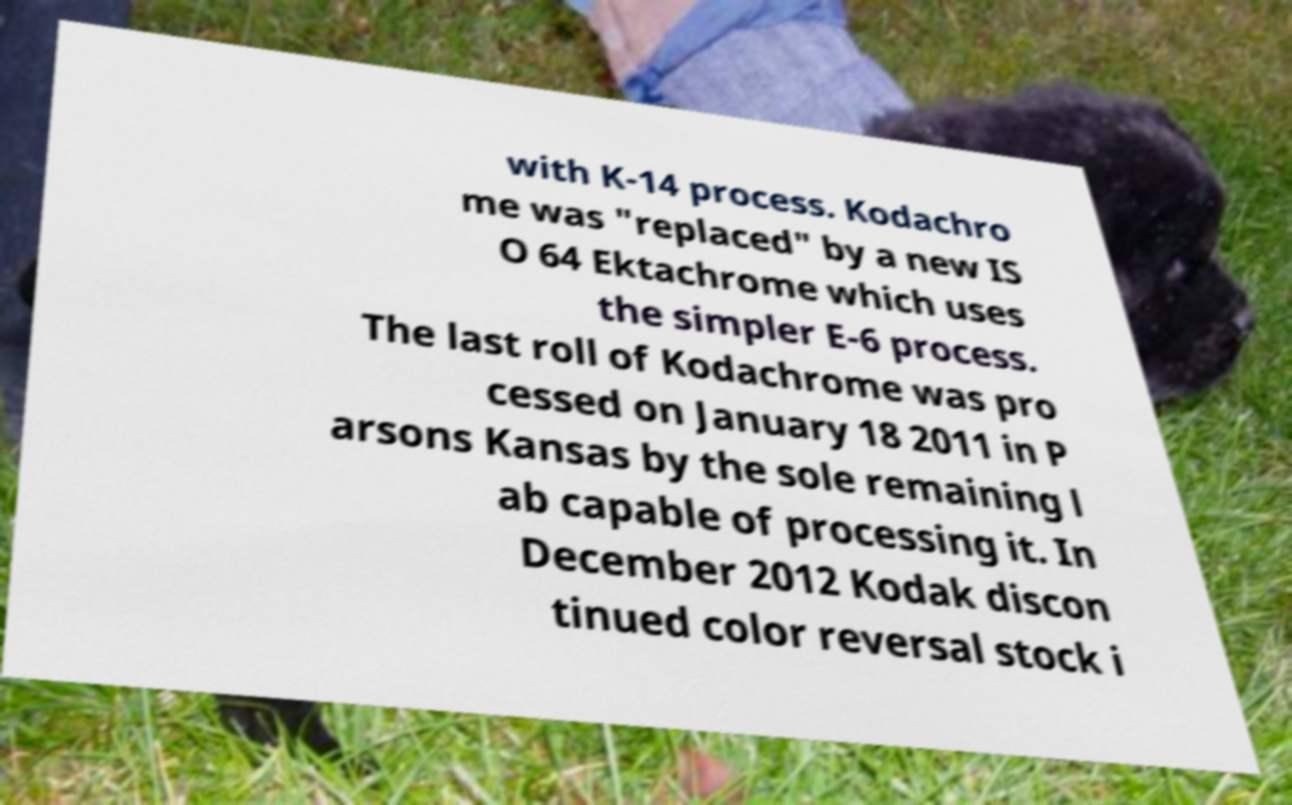There's text embedded in this image that I need extracted. Can you transcribe it verbatim? with K-14 process. Kodachro me was "replaced" by a new IS O 64 Ektachrome which uses the simpler E-6 process. The last roll of Kodachrome was pro cessed on January 18 2011 in P arsons Kansas by the sole remaining l ab capable of processing it. In December 2012 Kodak discon tinued color reversal stock i 